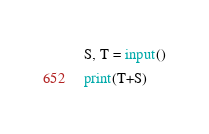Convert code to text. <code><loc_0><loc_0><loc_500><loc_500><_Python_>S, T = input()
print(T+S)</code> 